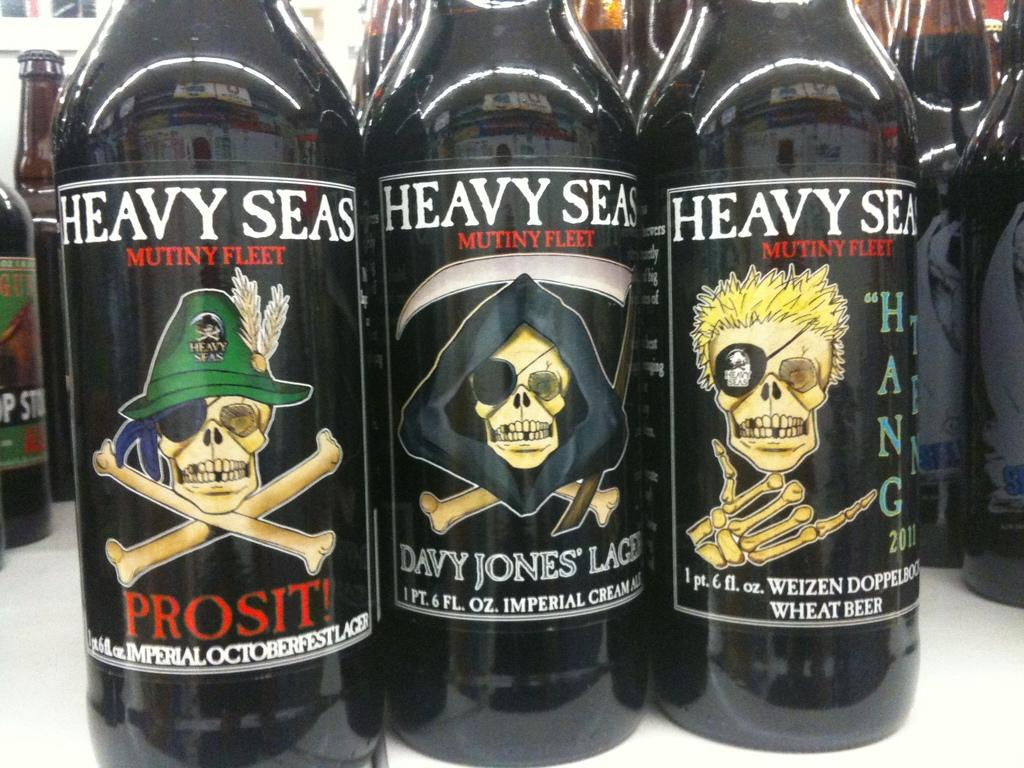<image>
Offer a succinct explanation of the picture presented. Several bottles of beer including at least three different varieties from the Heavy Seas Mutiny Fleet brand. 